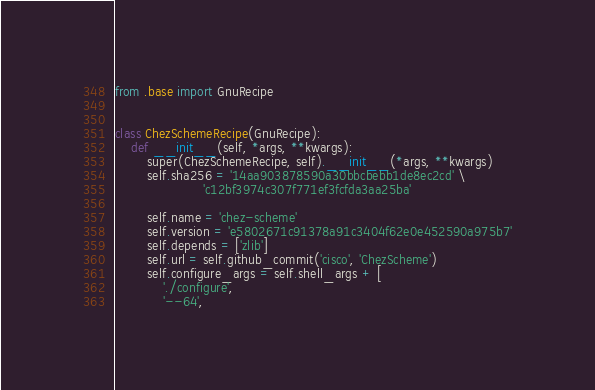<code> <loc_0><loc_0><loc_500><loc_500><_Python_>from .base import GnuRecipe


class ChezSchemeRecipe(GnuRecipe):
    def __init__(self, *args, **kwargs):
        super(ChezSchemeRecipe, self).__init__(*args, **kwargs)
        self.sha256 = '14aa903878590a30bbcbebb1de8ec2cd' \
                      'c12bf3974c307f771ef3fcfda3aa25ba'

        self.name = 'chez-scheme'
        self.version = 'e5802671c91378a91c3404f62e0e452590a975b7'
        self.depends = ['zlib']
        self.url = self.github_commit('cisco', 'ChezScheme')
        self.configure_args = self.shell_args + [
            './configure',
            '--64',</code> 